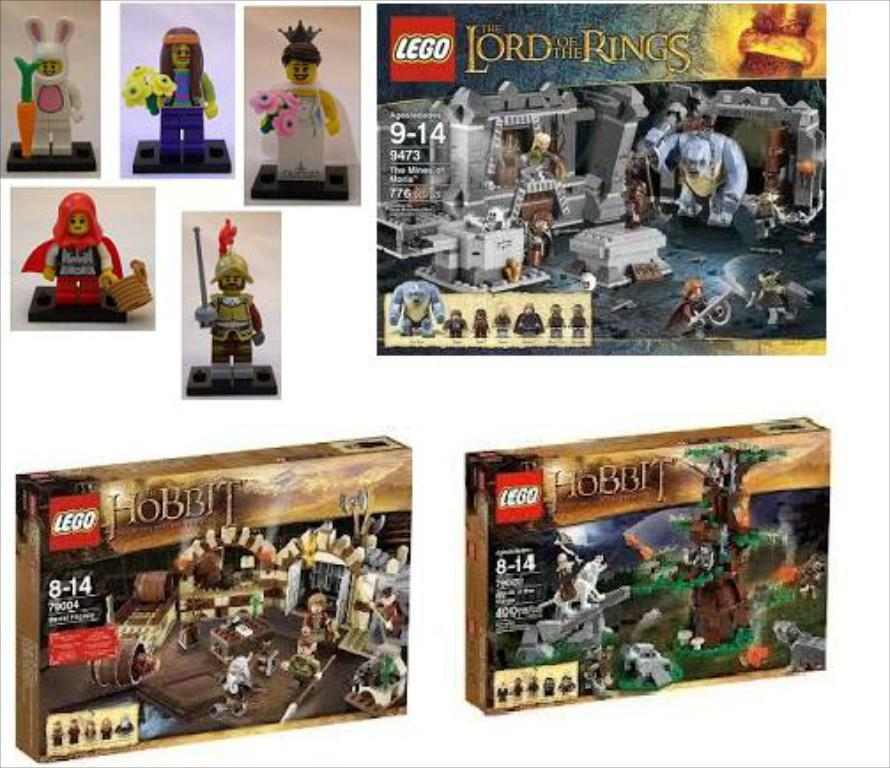What type of objects are present in the image that have images and text on them? There are boxes with images and text in the image. What other type of object with images can be seen in the image? There is a poster with images in the image. What type of objects are present in the image that are typically used for play? There are toys in the image. What type of sweater is being worn by the box in the image? There is no sweater present in the image, as the main subjects are boxes, a poster, and toys. 